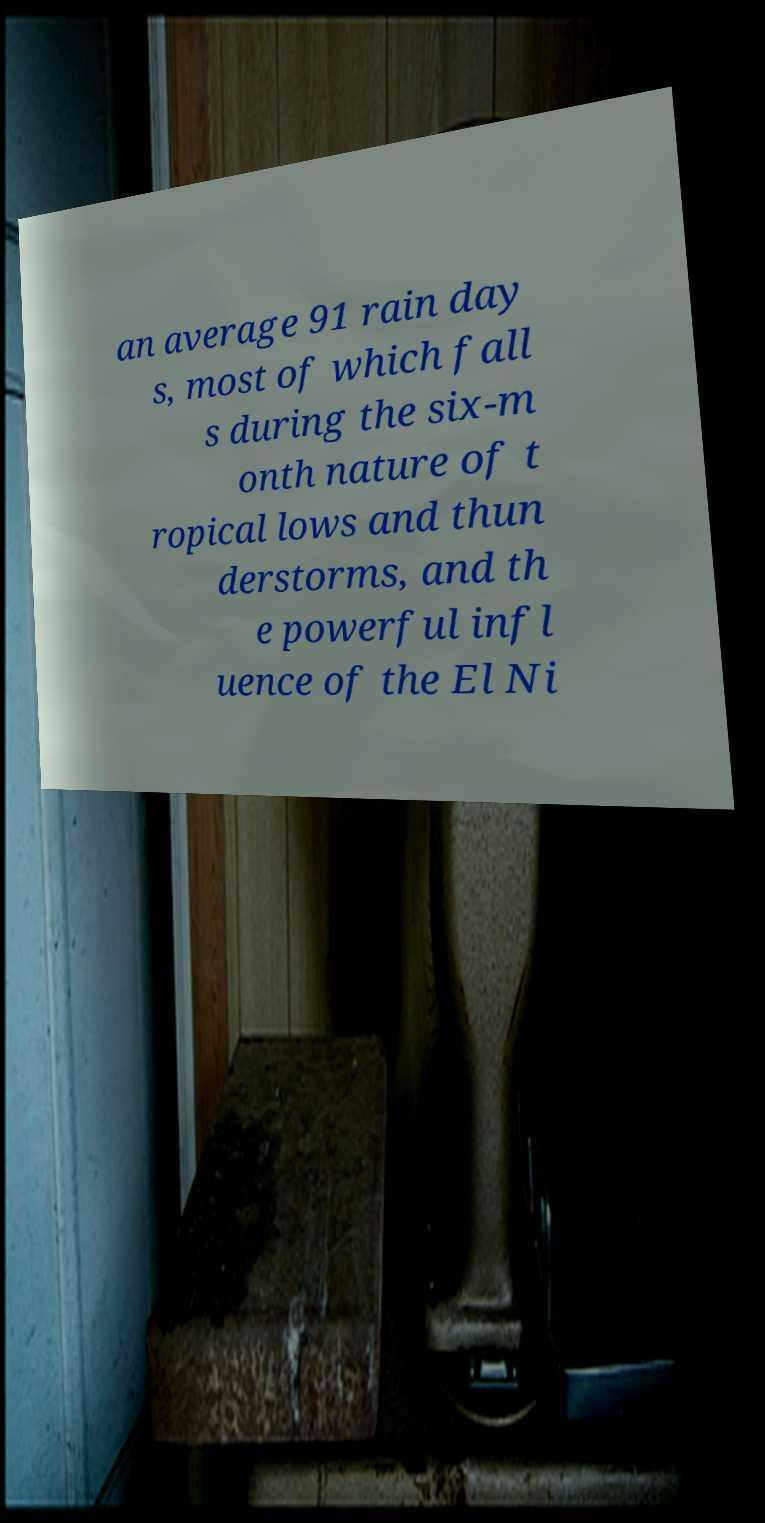Could you assist in decoding the text presented in this image and type it out clearly? an average 91 rain day s, most of which fall s during the six-m onth nature of t ropical lows and thun derstorms, and th e powerful infl uence of the El Ni 